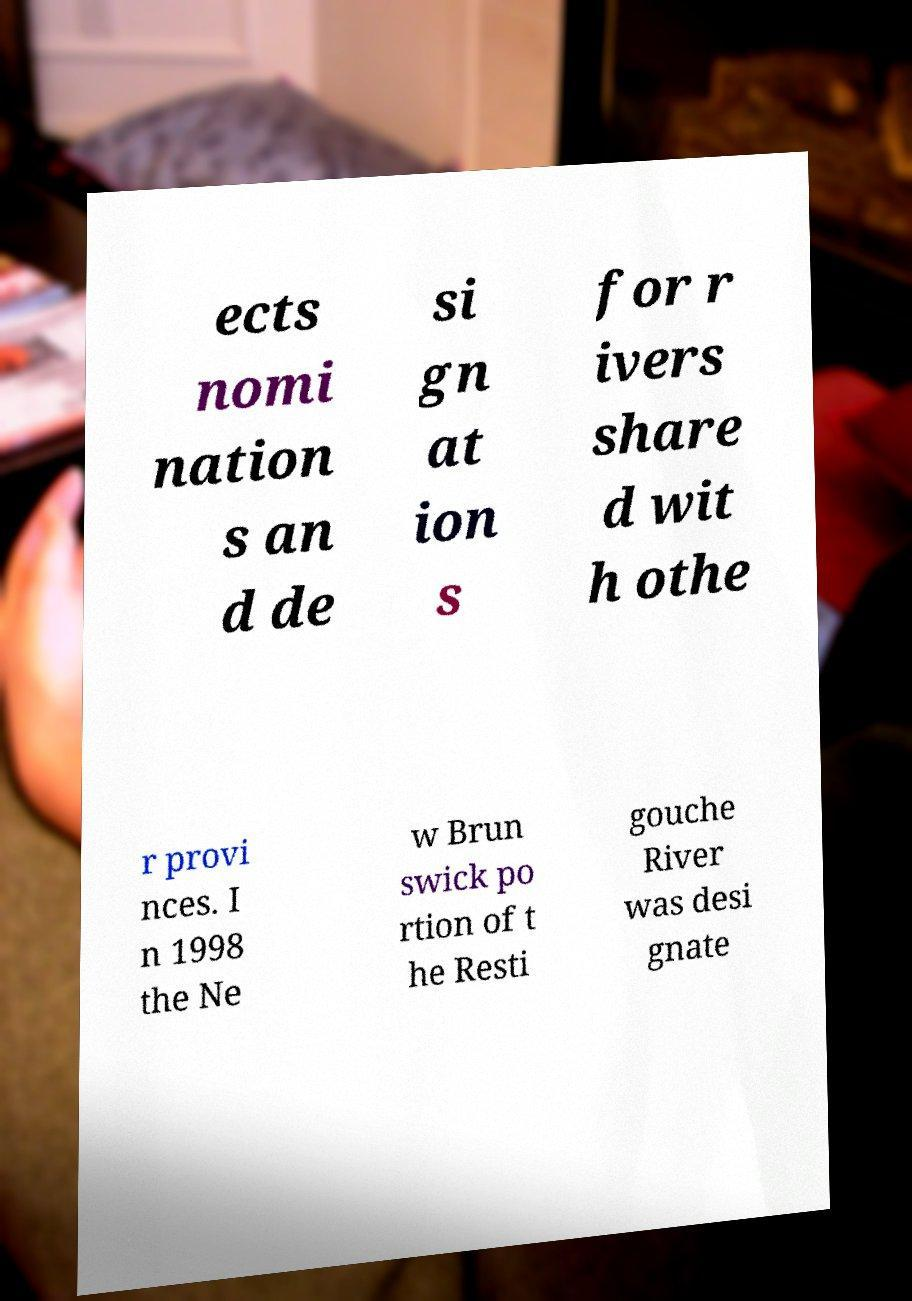Please identify and transcribe the text found in this image. ects nomi nation s an d de si gn at ion s for r ivers share d wit h othe r provi nces. I n 1998 the Ne w Brun swick po rtion of t he Resti gouche River was desi gnate 